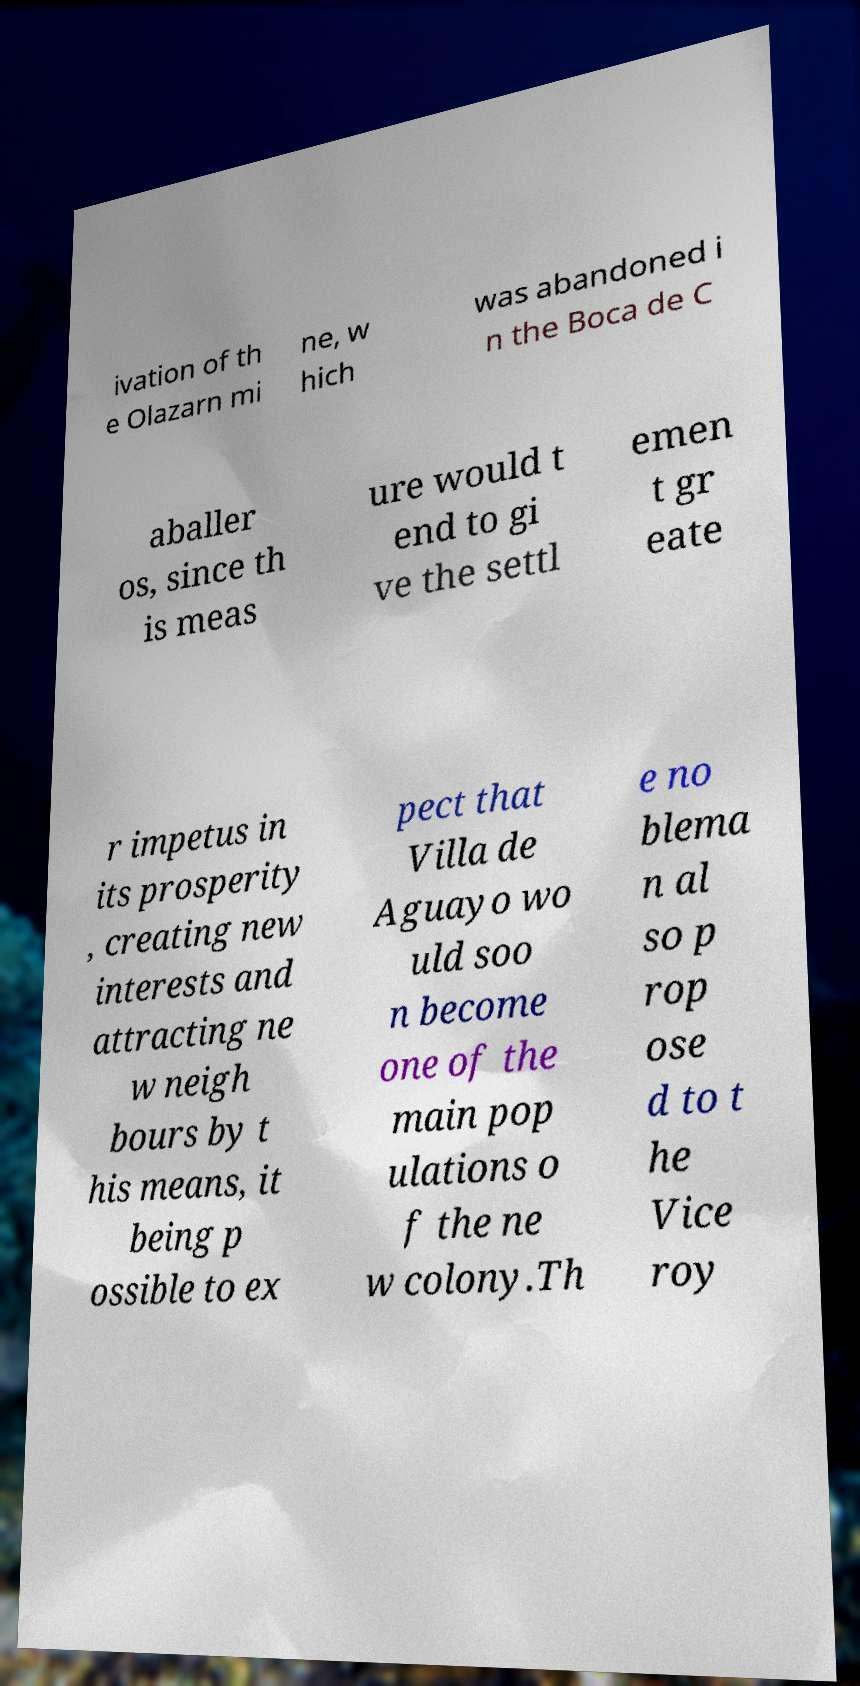Can you read and provide the text displayed in the image?This photo seems to have some interesting text. Can you extract and type it out for me? ivation of th e Olazarn mi ne, w hich was abandoned i n the Boca de C aballer os, since th is meas ure would t end to gi ve the settl emen t gr eate r impetus in its prosperity , creating new interests and attracting ne w neigh bours by t his means, it being p ossible to ex pect that Villa de Aguayo wo uld soo n become one of the main pop ulations o f the ne w colony.Th e no blema n al so p rop ose d to t he Vice roy 